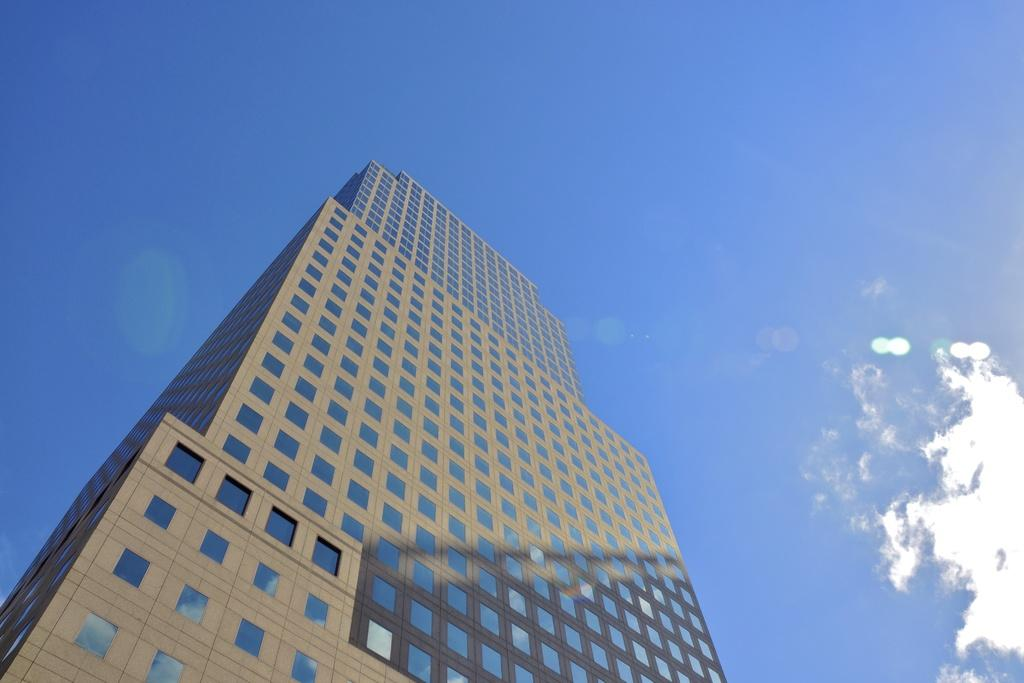What is the main subject in the center of the image? There is a building in the center of the image. What can be seen in the sky in the image? There are clouds visible at the top of the image. What type of vegetable is growing on the roof of the building in the image? There is no vegetable growing on the roof of the building in the image. Who is the owner of the building in the image? The image does not provide information about the owner of the building. 